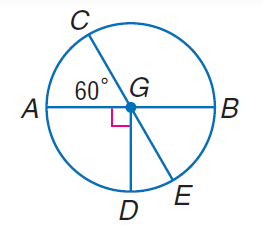What concept does this image help illustrate in geometry? This image illustrates several fundamental concepts in geometry related to circles. One key concept is central angles, which are angles whose vertex is the center of the circle and whose sides are radii, as seen with angle CGE. Another concept is the equality of radii in the same circle, which you can observe with segments DG, CG, and EG. The diagram is also useful for discussing chords and their properties; for instance, line segments DE, AB, and BC are chords of the circle. Lastly, this image could start a discussion on congruent arcs and their corresponding central angles, although specific measures are not provided in this case. 